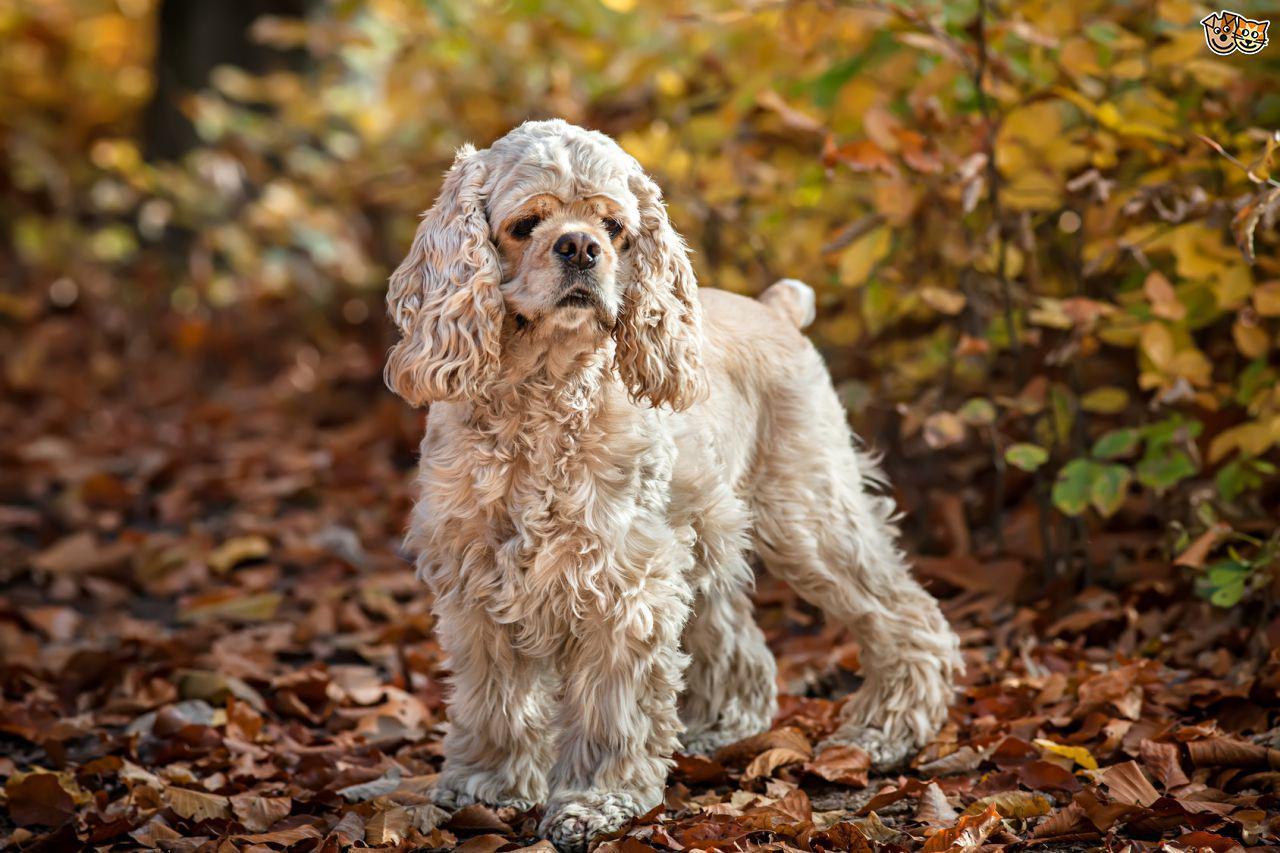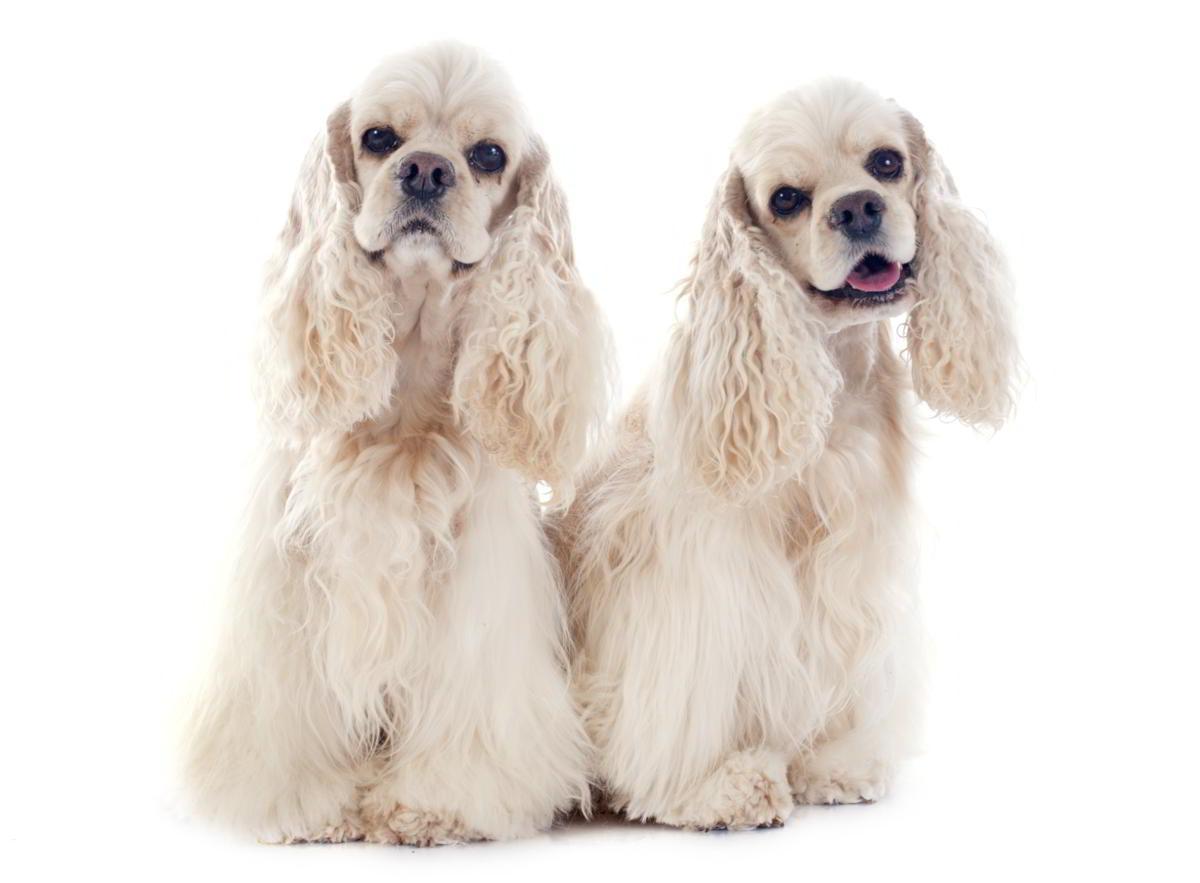The first image is the image on the left, the second image is the image on the right. For the images shown, is this caption "The dog in the image on the right is outside on the grass." true? Answer yes or no. No. The first image is the image on the left, the second image is the image on the right. Assess this claim about the two images: "The left image includes exactly twice as many spaniel dogs as the right image.". Correct or not? Answer yes or no. No. 